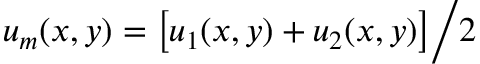Convert formula to latex. <formula><loc_0><loc_0><loc_500><loc_500>u _ { m } ( x , y ) = \left [ u _ { 1 } ( x , y ) + u _ { 2 } ( x , y ) \right ] \Big / 2</formula> 